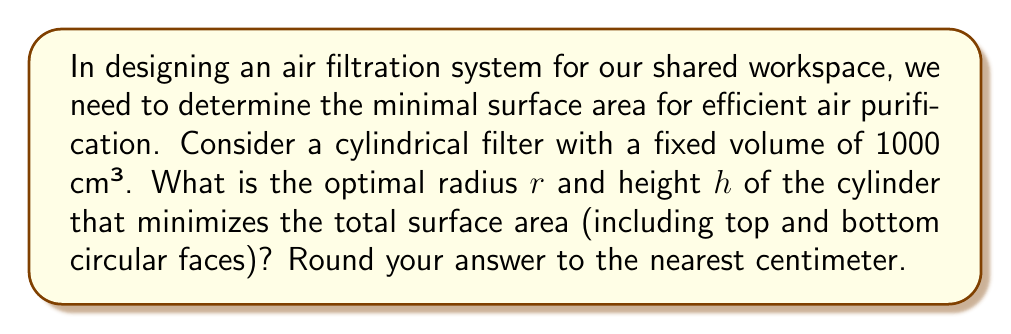Provide a solution to this math problem. Let's approach this step-by-step:

1) The volume of a cylinder is given by $V = \pi r^2 h$, where $r$ is the radius and $h$ is the height.

2) The surface area of a cylinder (including top and bottom) is given by $A = 2\pi r^2 + 2\pi rh$.

3) We're given that the volume is fixed at 1000 cm³, so:

   $$1000 = \pi r^2 h$$

4) Solve for $h$:

   $$h = \frac{1000}{\pi r^2}$$

5) Substitute this into the surface area equation:

   $$A = 2\pi r^2 + 2\pi r(\frac{1000}{\pi r^2})$$

6) Simplify:

   $$A = 2\pi r^2 + \frac{2000}{r}$$

7) To find the minimum, we differentiate $A$ with respect to $r$ and set it to zero:

   $$\frac{dA}{dr} = 4\pi r - \frac{2000}{r^2} = 0$$

8) Solve this equation:

   $$4\pi r^3 = 2000$$
   $$r^3 = \frac{500}{\pi}$$
   $$r = \sqrt[3]{\frac{500}{\pi}} \approx 5.42$$

9) Round to the nearest centimeter: $r = 5$ cm

10) To find $h$, use the volume equation:

    $$h = \frac{1000}{\pi r^2} = \frac{1000}{\pi (5^2)} \approx 12.73$$

11) Round to the nearest centimeter: $h = 13$ cm
Answer: $r = 5$ cm, $h = 13$ cm 